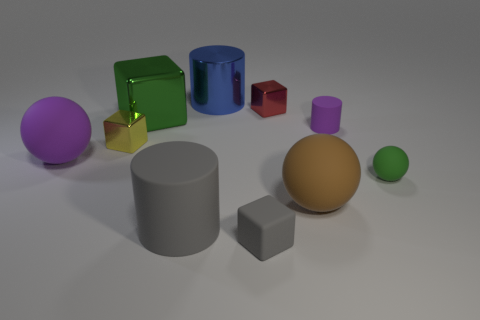Subtract all large metallic cylinders. How many cylinders are left? 2 Subtract all green cubes. How many cubes are left? 3 Subtract 0 yellow cylinders. How many objects are left? 10 Subtract all cylinders. How many objects are left? 7 Subtract 1 cubes. How many cubes are left? 3 Subtract all cyan cubes. Subtract all red cylinders. How many cubes are left? 4 Subtract all blue balls. How many cyan blocks are left? 0 Subtract all cylinders. Subtract all large rubber balls. How many objects are left? 5 Add 2 large brown rubber spheres. How many large brown rubber spheres are left? 3 Add 3 small cyan rubber balls. How many small cyan rubber balls exist? 3 